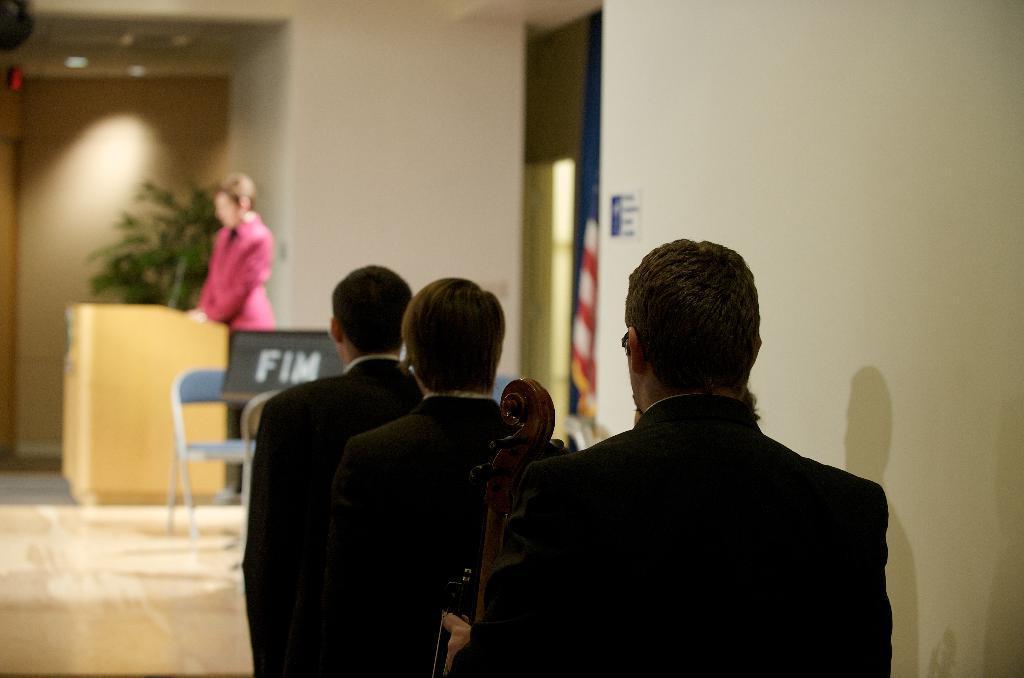How would you summarize this image in a sentence or two? In this image there are three men standing in a queue. They are holding musical instruments. In front of them there are chairs. Behind the chairs there is a woman standing at the podium. In the background there is a wall. There are flags and a houseplant at the wall. 